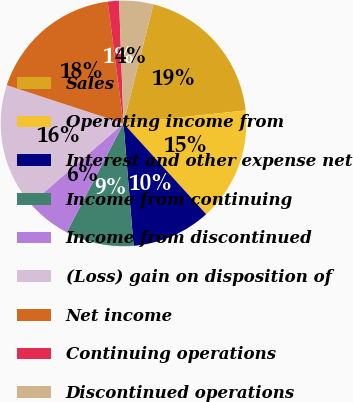Convert chart to OTSL. <chart><loc_0><loc_0><loc_500><loc_500><pie_chart><fcel>Sales<fcel>Operating income from<fcel>Interest and other expense net<fcel>Income from continuing<fcel>Income from discontinued<fcel>(Loss) gain on disposition of<fcel>Net income<fcel>Continuing operations<fcel>Discontinued operations<nl><fcel>19.4%<fcel>14.93%<fcel>10.45%<fcel>8.96%<fcel>5.97%<fcel>16.42%<fcel>17.91%<fcel>1.49%<fcel>4.48%<nl></chart> 